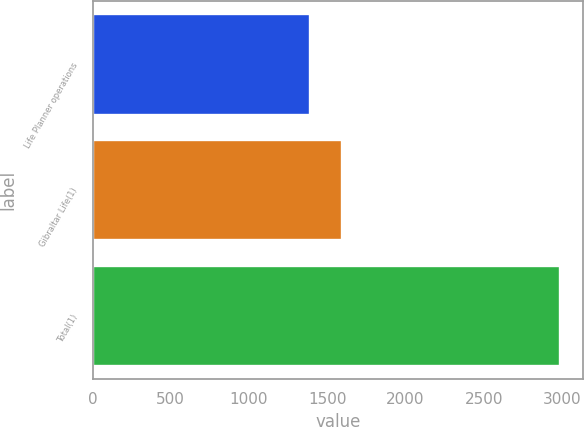Convert chart to OTSL. <chart><loc_0><loc_0><loc_500><loc_500><bar_chart><fcel>Life Planner operations<fcel>Gibraltar Life(1)<fcel>Total(1)<nl><fcel>1391<fcel>1595<fcel>2986<nl></chart> 